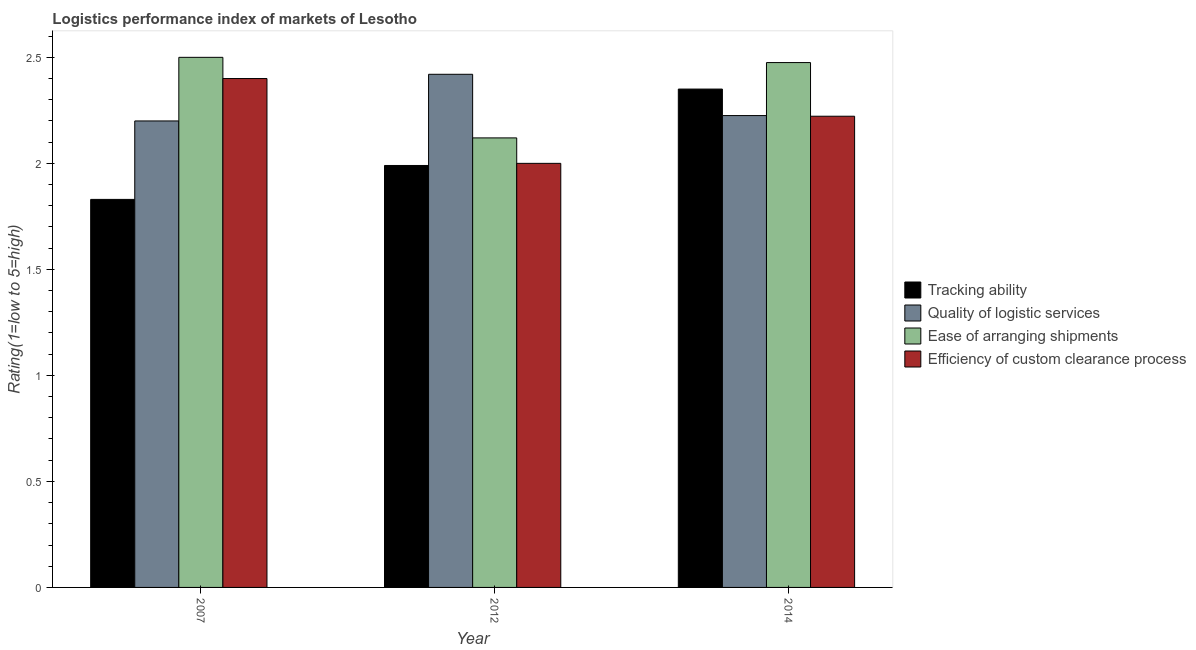Are the number of bars per tick equal to the number of legend labels?
Provide a succinct answer. Yes. Are the number of bars on each tick of the X-axis equal?
Keep it short and to the point. Yes. How many bars are there on the 3rd tick from the right?
Offer a terse response. 4. What is the lpi rating of tracking ability in 2012?
Your answer should be compact. 1.99. Across all years, what is the maximum lpi rating of quality of logistic services?
Your response must be concise. 2.42. Across all years, what is the minimum lpi rating of quality of logistic services?
Offer a terse response. 2.2. In which year was the lpi rating of ease of arranging shipments minimum?
Offer a terse response. 2012. What is the total lpi rating of efficiency of custom clearance process in the graph?
Give a very brief answer. 6.62. What is the difference between the lpi rating of quality of logistic services in 2007 and that in 2014?
Offer a very short reply. -0.03. What is the difference between the lpi rating of ease of arranging shipments in 2014 and the lpi rating of tracking ability in 2007?
Ensure brevity in your answer.  -0.02. What is the average lpi rating of quality of logistic services per year?
Provide a succinct answer. 2.28. In the year 2012, what is the difference between the lpi rating of quality of logistic services and lpi rating of ease of arranging shipments?
Provide a succinct answer. 0. In how many years, is the lpi rating of quality of logistic services greater than 1.8?
Offer a very short reply. 3. What is the ratio of the lpi rating of ease of arranging shipments in 2012 to that in 2014?
Offer a terse response. 0.86. Is the lpi rating of ease of arranging shipments in 2007 less than that in 2014?
Provide a short and direct response. No. What is the difference between the highest and the second highest lpi rating of tracking ability?
Your answer should be very brief. 0.36. What is the difference between the highest and the lowest lpi rating of efficiency of custom clearance process?
Offer a very short reply. 0.4. In how many years, is the lpi rating of tracking ability greater than the average lpi rating of tracking ability taken over all years?
Give a very brief answer. 1. Is the sum of the lpi rating of ease of arranging shipments in 2007 and 2012 greater than the maximum lpi rating of quality of logistic services across all years?
Keep it short and to the point. Yes. Is it the case that in every year, the sum of the lpi rating of ease of arranging shipments and lpi rating of efficiency of custom clearance process is greater than the sum of lpi rating of quality of logistic services and lpi rating of tracking ability?
Your answer should be very brief. No. What does the 3rd bar from the left in 2007 represents?
Provide a short and direct response. Ease of arranging shipments. What does the 4th bar from the right in 2012 represents?
Ensure brevity in your answer.  Tracking ability. How many bars are there?
Offer a very short reply. 12. How many years are there in the graph?
Make the answer very short. 3. Does the graph contain any zero values?
Offer a terse response. No. How many legend labels are there?
Offer a terse response. 4. What is the title of the graph?
Give a very brief answer. Logistics performance index of markets of Lesotho. Does "Secondary vocational education" appear as one of the legend labels in the graph?
Your response must be concise. No. What is the label or title of the Y-axis?
Give a very brief answer. Rating(1=low to 5=high). What is the Rating(1=low to 5=high) in Tracking ability in 2007?
Your answer should be very brief. 1.83. What is the Rating(1=low to 5=high) of Quality of logistic services in 2007?
Your answer should be compact. 2.2. What is the Rating(1=low to 5=high) of Efficiency of custom clearance process in 2007?
Your response must be concise. 2.4. What is the Rating(1=low to 5=high) in Tracking ability in 2012?
Make the answer very short. 1.99. What is the Rating(1=low to 5=high) in Quality of logistic services in 2012?
Ensure brevity in your answer.  2.42. What is the Rating(1=low to 5=high) of Ease of arranging shipments in 2012?
Give a very brief answer. 2.12. What is the Rating(1=low to 5=high) of Efficiency of custom clearance process in 2012?
Keep it short and to the point. 2. What is the Rating(1=low to 5=high) of Tracking ability in 2014?
Make the answer very short. 2.35. What is the Rating(1=low to 5=high) in Quality of logistic services in 2014?
Provide a succinct answer. 2.23. What is the Rating(1=low to 5=high) in Ease of arranging shipments in 2014?
Offer a terse response. 2.48. What is the Rating(1=low to 5=high) in Efficiency of custom clearance process in 2014?
Offer a very short reply. 2.22. Across all years, what is the maximum Rating(1=low to 5=high) in Tracking ability?
Offer a very short reply. 2.35. Across all years, what is the maximum Rating(1=low to 5=high) of Quality of logistic services?
Give a very brief answer. 2.42. Across all years, what is the maximum Rating(1=low to 5=high) of Ease of arranging shipments?
Make the answer very short. 2.5. Across all years, what is the maximum Rating(1=low to 5=high) in Efficiency of custom clearance process?
Offer a very short reply. 2.4. Across all years, what is the minimum Rating(1=low to 5=high) of Tracking ability?
Your response must be concise. 1.83. Across all years, what is the minimum Rating(1=low to 5=high) of Ease of arranging shipments?
Ensure brevity in your answer.  2.12. Across all years, what is the minimum Rating(1=low to 5=high) in Efficiency of custom clearance process?
Offer a terse response. 2. What is the total Rating(1=low to 5=high) in Tracking ability in the graph?
Provide a short and direct response. 6.17. What is the total Rating(1=low to 5=high) in Quality of logistic services in the graph?
Provide a short and direct response. 6.85. What is the total Rating(1=low to 5=high) of Ease of arranging shipments in the graph?
Keep it short and to the point. 7.1. What is the total Rating(1=low to 5=high) in Efficiency of custom clearance process in the graph?
Ensure brevity in your answer.  6.62. What is the difference between the Rating(1=low to 5=high) in Tracking ability in 2007 and that in 2012?
Give a very brief answer. -0.16. What is the difference between the Rating(1=low to 5=high) of Quality of logistic services in 2007 and that in 2012?
Keep it short and to the point. -0.22. What is the difference between the Rating(1=low to 5=high) in Ease of arranging shipments in 2007 and that in 2012?
Give a very brief answer. 0.38. What is the difference between the Rating(1=low to 5=high) of Efficiency of custom clearance process in 2007 and that in 2012?
Provide a succinct answer. 0.4. What is the difference between the Rating(1=low to 5=high) in Tracking ability in 2007 and that in 2014?
Offer a very short reply. -0.52. What is the difference between the Rating(1=low to 5=high) of Quality of logistic services in 2007 and that in 2014?
Give a very brief answer. -0.03. What is the difference between the Rating(1=low to 5=high) of Ease of arranging shipments in 2007 and that in 2014?
Your answer should be very brief. 0.02. What is the difference between the Rating(1=low to 5=high) in Efficiency of custom clearance process in 2007 and that in 2014?
Make the answer very short. 0.18. What is the difference between the Rating(1=low to 5=high) of Tracking ability in 2012 and that in 2014?
Offer a very short reply. -0.36. What is the difference between the Rating(1=low to 5=high) of Quality of logistic services in 2012 and that in 2014?
Give a very brief answer. 0.19. What is the difference between the Rating(1=low to 5=high) in Ease of arranging shipments in 2012 and that in 2014?
Give a very brief answer. -0.36. What is the difference between the Rating(1=low to 5=high) of Efficiency of custom clearance process in 2012 and that in 2014?
Your response must be concise. -0.22. What is the difference between the Rating(1=low to 5=high) in Tracking ability in 2007 and the Rating(1=low to 5=high) in Quality of logistic services in 2012?
Keep it short and to the point. -0.59. What is the difference between the Rating(1=low to 5=high) in Tracking ability in 2007 and the Rating(1=low to 5=high) in Ease of arranging shipments in 2012?
Make the answer very short. -0.29. What is the difference between the Rating(1=low to 5=high) in Tracking ability in 2007 and the Rating(1=low to 5=high) in Efficiency of custom clearance process in 2012?
Your answer should be very brief. -0.17. What is the difference between the Rating(1=low to 5=high) of Quality of logistic services in 2007 and the Rating(1=low to 5=high) of Efficiency of custom clearance process in 2012?
Your response must be concise. 0.2. What is the difference between the Rating(1=low to 5=high) in Ease of arranging shipments in 2007 and the Rating(1=low to 5=high) in Efficiency of custom clearance process in 2012?
Ensure brevity in your answer.  0.5. What is the difference between the Rating(1=low to 5=high) in Tracking ability in 2007 and the Rating(1=low to 5=high) in Quality of logistic services in 2014?
Your response must be concise. -0.4. What is the difference between the Rating(1=low to 5=high) in Tracking ability in 2007 and the Rating(1=low to 5=high) in Ease of arranging shipments in 2014?
Provide a succinct answer. -0.65. What is the difference between the Rating(1=low to 5=high) of Tracking ability in 2007 and the Rating(1=low to 5=high) of Efficiency of custom clearance process in 2014?
Keep it short and to the point. -0.39. What is the difference between the Rating(1=low to 5=high) of Quality of logistic services in 2007 and the Rating(1=low to 5=high) of Ease of arranging shipments in 2014?
Provide a short and direct response. -0.28. What is the difference between the Rating(1=low to 5=high) in Quality of logistic services in 2007 and the Rating(1=low to 5=high) in Efficiency of custom clearance process in 2014?
Provide a succinct answer. -0.02. What is the difference between the Rating(1=low to 5=high) in Ease of arranging shipments in 2007 and the Rating(1=low to 5=high) in Efficiency of custom clearance process in 2014?
Make the answer very short. 0.28. What is the difference between the Rating(1=low to 5=high) in Tracking ability in 2012 and the Rating(1=low to 5=high) in Quality of logistic services in 2014?
Make the answer very short. -0.24. What is the difference between the Rating(1=low to 5=high) in Tracking ability in 2012 and the Rating(1=low to 5=high) in Ease of arranging shipments in 2014?
Make the answer very short. -0.49. What is the difference between the Rating(1=low to 5=high) of Tracking ability in 2012 and the Rating(1=low to 5=high) of Efficiency of custom clearance process in 2014?
Ensure brevity in your answer.  -0.23. What is the difference between the Rating(1=low to 5=high) of Quality of logistic services in 2012 and the Rating(1=low to 5=high) of Ease of arranging shipments in 2014?
Ensure brevity in your answer.  -0.06. What is the difference between the Rating(1=low to 5=high) of Quality of logistic services in 2012 and the Rating(1=low to 5=high) of Efficiency of custom clearance process in 2014?
Make the answer very short. 0.2. What is the difference between the Rating(1=low to 5=high) of Ease of arranging shipments in 2012 and the Rating(1=low to 5=high) of Efficiency of custom clearance process in 2014?
Offer a very short reply. -0.1. What is the average Rating(1=low to 5=high) of Tracking ability per year?
Give a very brief answer. 2.06. What is the average Rating(1=low to 5=high) of Quality of logistic services per year?
Keep it short and to the point. 2.28. What is the average Rating(1=low to 5=high) of Ease of arranging shipments per year?
Your response must be concise. 2.37. What is the average Rating(1=low to 5=high) in Efficiency of custom clearance process per year?
Keep it short and to the point. 2.21. In the year 2007, what is the difference between the Rating(1=low to 5=high) of Tracking ability and Rating(1=low to 5=high) of Quality of logistic services?
Your response must be concise. -0.37. In the year 2007, what is the difference between the Rating(1=low to 5=high) in Tracking ability and Rating(1=low to 5=high) in Ease of arranging shipments?
Give a very brief answer. -0.67. In the year 2007, what is the difference between the Rating(1=low to 5=high) of Tracking ability and Rating(1=low to 5=high) of Efficiency of custom clearance process?
Offer a terse response. -0.57. In the year 2007, what is the difference between the Rating(1=low to 5=high) of Quality of logistic services and Rating(1=low to 5=high) of Efficiency of custom clearance process?
Your answer should be compact. -0.2. In the year 2007, what is the difference between the Rating(1=low to 5=high) of Ease of arranging shipments and Rating(1=low to 5=high) of Efficiency of custom clearance process?
Make the answer very short. 0.1. In the year 2012, what is the difference between the Rating(1=low to 5=high) in Tracking ability and Rating(1=low to 5=high) in Quality of logistic services?
Your answer should be very brief. -0.43. In the year 2012, what is the difference between the Rating(1=low to 5=high) in Tracking ability and Rating(1=low to 5=high) in Ease of arranging shipments?
Keep it short and to the point. -0.13. In the year 2012, what is the difference between the Rating(1=low to 5=high) of Tracking ability and Rating(1=low to 5=high) of Efficiency of custom clearance process?
Your answer should be compact. -0.01. In the year 2012, what is the difference between the Rating(1=low to 5=high) of Quality of logistic services and Rating(1=low to 5=high) of Efficiency of custom clearance process?
Make the answer very short. 0.42. In the year 2012, what is the difference between the Rating(1=low to 5=high) of Ease of arranging shipments and Rating(1=low to 5=high) of Efficiency of custom clearance process?
Provide a succinct answer. 0.12. In the year 2014, what is the difference between the Rating(1=low to 5=high) of Tracking ability and Rating(1=low to 5=high) of Quality of logistic services?
Your answer should be very brief. 0.12. In the year 2014, what is the difference between the Rating(1=low to 5=high) of Tracking ability and Rating(1=low to 5=high) of Ease of arranging shipments?
Your response must be concise. -0.12. In the year 2014, what is the difference between the Rating(1=low to 5=high) in Tracking ability and Rating(1=low to 5=high) in Efficiency of custom clearance process?
Ensure brevity in your answer.  0.13. In the year 2014, what is the difference between the Rating(1=low to 5=high) of Quality of logistic services and Rating(1=low to 5=high) of Ease of arranging shipments?
Offer a very short reply. -0.25. In the year 2014, what is the difference between the Rating(1=low to 5=high) in Quality of logistic services and Rating(1=low to 5=high) in Efficiency of custom clearance process?
Provide a succinct answer. 0. In the year 2014, what is the difference between the Rating(1=low to 5=high) in Ease of arranging shipments and Rating(1=low to 5=high) in Efficiency of custom clearance process?
Offer a very short reply. 0.25. What is the ratio of the Rating(1=low to 5=high) of Tracking ability in 2007 to that in 2012?
Ensure brevity in your answer.  0.92. What is the ratio of the Rating(1=low to 5=high) in Quality of logistic services in 2007 to that in 2012?
Your answer should be very brief. 0.91. What is the ratio of the Rating(1=low to 5=high) of Ease of arranging shipments in 2007 to that in 2012?
Make the answer very short. 1.18. What is the ratio of the Rating(1=low to 5=high) of Efficiency of custom clearance process in 2007 to that in 2012?
Provide a short and direct response. 1.2. What is the ratio of the Rating(1=low to 5=high) in Tracking ability in 2007 to that in 2014?
Ensure brevity in your answer.  0.78. What is the ratio of the Rating(1=low to 5=high) in Efficiency of custom clearance process in 2007 to that in 2014?
Provide a succinct answer. 1.08. What is the ratio of the Rating(1=low to 5=high) in Tracking ability in 2012 to that in 2014?
Offer a very short reply. 0.85. What is the ratio of the Rating(1=low to 5=high) of Quality of logistic services in 2012 to that in 2014?
Ensure brevity in your answer.  1.09. What is the ratio of the Rating(1=low to 5=high) in Ease of arranging shipments in 2012 to that in 2014?
Ensure brevity in your answer.  0.86. What is the difference between the highest and the second highest Rating(1=low to 5=high) in Tracking ability?
Your answer should be very brief. 0.36. What is the difference between the highest and the second highest Rating(1=low to 5=high) of Quality of logistic services?
Provide a short and direct response. 0.19. What is the difference between the highest and the second highest Rating(1=low to 5=high) in Ease of arranging shipments?
Keep it short and to the point. 0.02. What is the difference between the highest and the second highest Rating(1=low to 5=high) in Efficiency of custom clearance process?
Give a very brief answer. 0.18. What is the difference between the highest and the lowest Rating(1=low to 5=high) in Tracking ability?
Make the answer very short. 0.52. What is the difference between the highest and the lowest Rating(1=low to 5=high) in Quality of logistic services?
Make the answer very short. 0.22. What is the difference between the highest and the lowest Rating(1=low to 5=high) in Ease of arranging shipments?
Keep it short and to the point. 0.38. What is the difference between the highest and the lowest Rating(1=low to 5=high) of Efficiency of custom clearance process?
Make the answer very short. 0.4. 